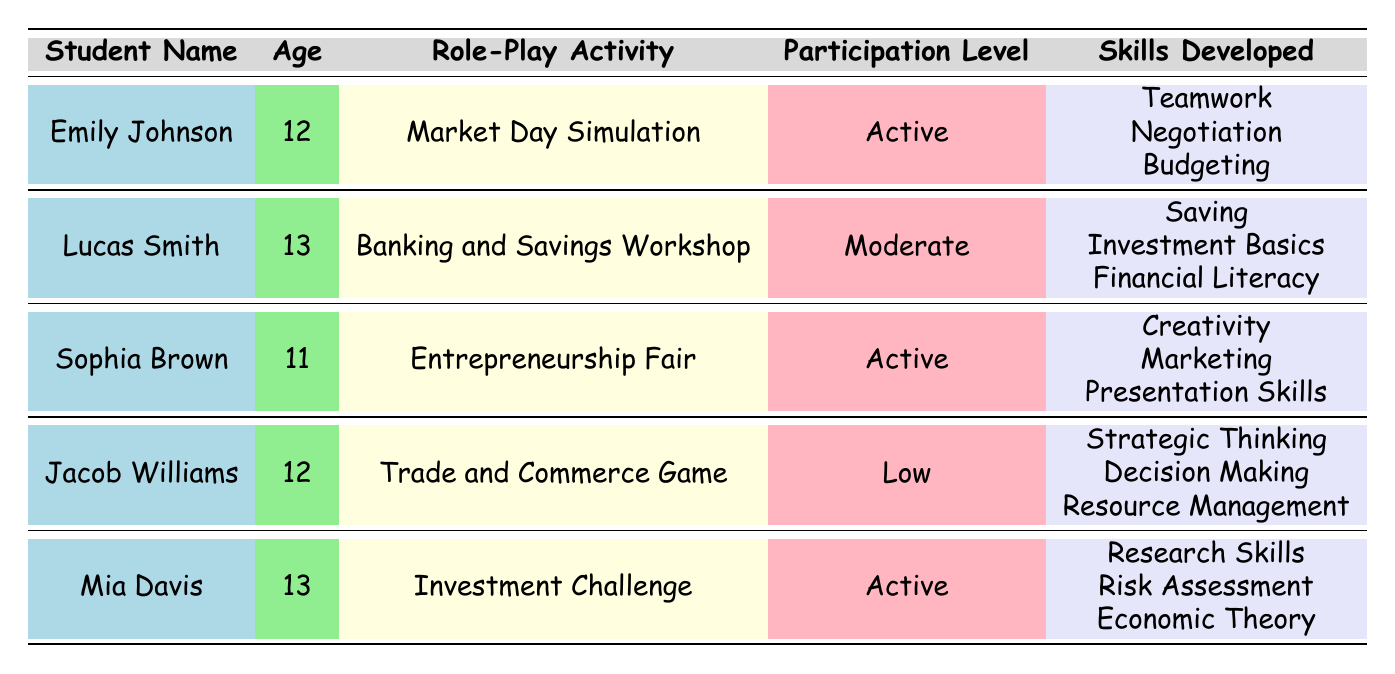What is the participation level of Mia Davis? Mia Davis is listed in the table and her participation level is mentioned in the corresponding row. It is "Active."
Answer: Active Which student developed skills in "Teamwork," "Negotiation," and "Budgeting"? The student associated with these skills is Emily Johnson, as noted in her row in the table.
Answer: Emily Johnson How many students participated in the "Market Day Simulation"? The table shows that only one student, Emily Johnson, participated in this activity. Therefore, the count is one.
Answer: 1 Is Sophia Brown older than Jacob Williams? Sophia Brown is 11 years old and Jacob Williams is 12 years old. Since 11 is less than 12, Sophia is not older than Jacob.
Answer: No What is the average age of the students participating in these activities? To find the average, sum the ages of all students: 12 + 13 + 11 + 12 + 13 = 61. There are 5 students, so the average age is 61 divided by 5, which is 12.2.
Answer: 12.2 Which students participated at an "Active" level? By reviewing the "Participation Level" column, the students with an "Active" participation level are Emily Johnson, Sophia Brown, and Mia Davis.
Answer: Emily Johnson, Sophia Brown, Mia Davis Did any student participate in more than one activity? The table indicates each student is associated with a single activity only; therefore, no student participated in more than one.
Answer: No How many skills were developed by Lucas Smith during his activity? Lucas Smith developed three skills as indicated in his row: "Saving," "Investment Basics," and "Financial Literacy."
Answer: 3 Which role-play activity had the lowest participation level, and who participated in it? The "Trade and Commerce Game" had the lowest participation level, which was "Low." Jacob Williams is the student associated with this activity.
Answer: Trade and Commerce Game, Jacob Williams 